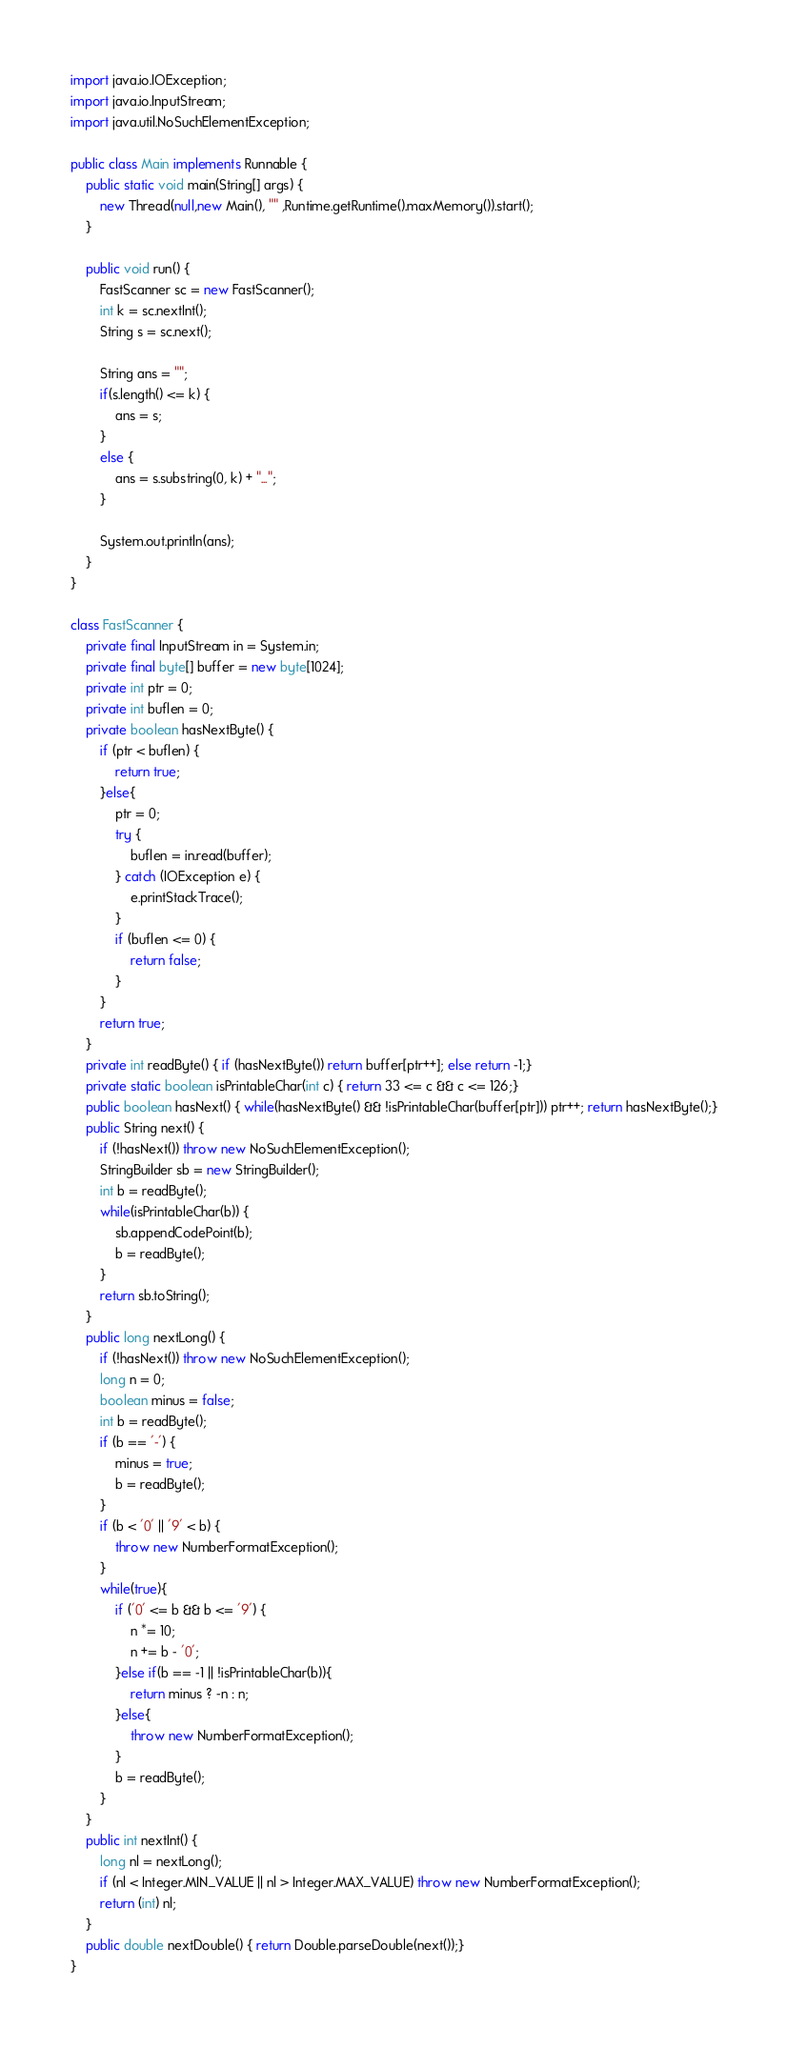Convert code to text. <code><loc_0><loc_0><loc_500><loc_500><_Java_>import java.io.IOException;
import java.io.InputStream;
import java.util.NoSuchElementException;

public class Main implements Runnable {
    public static void main(String[] args) {
        new Thread(null,new Main(), "" ,Runtime.getRuntime().maxMemory()).start();
    }

    public void run() {
        FastScanner sc = new FastScanner();
        int k = sc.nextInt();
        String s = sc.next();

        String ans = "";
        if(s.length() <= k) {
            ans = s;
        }
        else {
            ans = s.substring(0, k) + "...";
        }
        
        System.out.println(ans);
    }
}

class FastScanner {
    private final InputStream in = System.in;
    private final byte[] buffer = new byte[1024];
    private int ptr = 0;
    private int buflen = 0;
    private boolean hasNextByte() {
        if (ptr < buflen) {
            return true;
        }else{
            ptr = 0;
            try {
                buflen = in.read(buffer);
            } catch (IOException e) {
                e.printStackTrace();
            }
            if (buflen <= 0) {
                return false;
            }
        }
        return true;
    }
    private int readByte() { if (hasNextByte()) return buffer[ptr++]; else return -1;}
    private static boolean isPrintableChar(int c) { return 33 <= c && c <= 126;}
    public boolean hasNext() { while(hasNextByte() && !isPrintableChar(buffer[ptr])) ptr++; return hasNextByte();}
    public String next() {
        if (!hasNext()) throw new NoSuchElementException();
        StringBuilder sb = new StringBuilder();
        int b = readByte();
        while(isPrintableChar(b)) {
            sb.appendCodePoint(b);
            b = readByte();
        }
        return sb.toString();
    }
    public long nextLong() {
        if (!hasNext()) throw new NoSuchElementException();
        long n = 0;
        boolean minus = false;
        int b = readByte();
        if (b == '-') {
            minus = true;
            b = readByte();
        }
        if (b < '0' || '9' < b) {
            throw new NumberFormatException();
        }
        while(true){
            if ('0' <= b && b <= '9') {
                n *= 10;
                n += b - '0';
            }else if(b == -1 || !isPrintableChar(b)){
                return minus ? -n : n;
            }else{
                throw new NumberFormatException();
            }
            b = readByte();
        }
    }
    public int nextInt() {
        long nl = nextLong();
        if (nl < Integer.MIN_VALUE || nl > Integer.MAX_VALUE) throw new NumberFormatException();
        return (int) nl;
    }
    public double nextDouble() { return Double.parseDouble(next());}
}</code> 